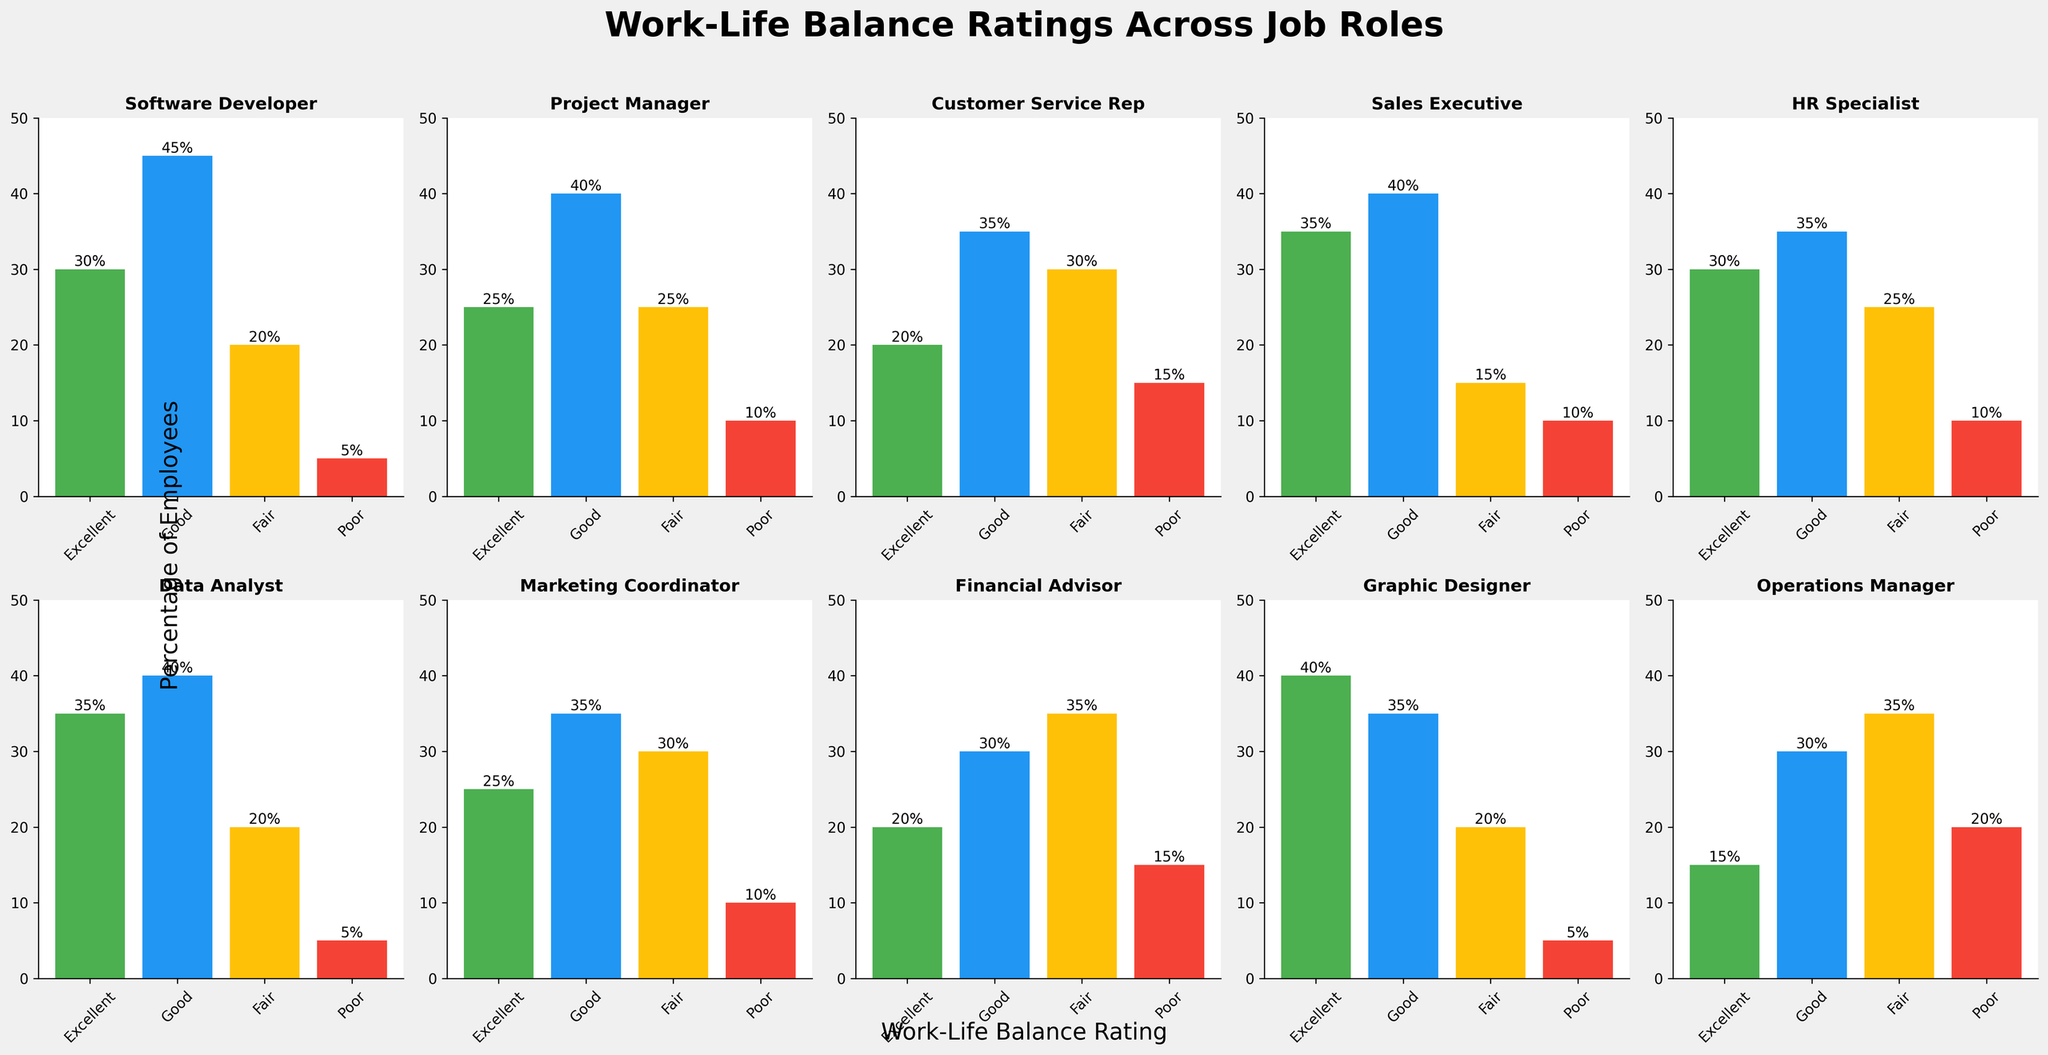What is the title of the figure? The title of the figure is usually placed at the top center and is typically printed in bold for better visibility. In this case, since the plot generation code specifies the title at the beginning, the title is "Work-Life Balance Ratings Across Job Roles."
Answer: Work-Life Balance Ratings Across Job Roles What job role has the highest percentage of employees rating their work-life balance as poor? The bar representing the percentage of employees rating their work-life balance as poor is the one with the red color ('#F44336'). By examining the graph, the Operations Manager role shows the highest percentage for the poor rating category, at 20%.
Answer: Operations Manager Which job role has the most employees rating their work-life balance as excellent? The green bar represents the excellent rating ('#4CAF50'). By looking at the height of these green bars, the job role with the tallest green bar can be identified. The Graphic Designer role has the highest percentage of employees rating their work-life balance as excellent, at 40%.
Answer: Graphic Designer What is the combined percentage of employees in the Customer Service Rep category who rated their work-life balance as either fair or poor? To find this combined percentage, add the values represented by the yellow (fair) and red (poor) bars for the Customer Service Rep role. The yellow bar is 30% and the red bar is 15%, so the combined percentage is 30% + 15% = 45%.
Answer: 45% Compare the "Good" ratings between Software Developer and Project Manager roles. Which one has a higher percentage? To compare, look at the blue bars for both roles. The Software Developer role has a blue bar at 45%, while the Project Manager role has a blue bar at 40%. Therefore, the Software Developer role has a higher percentage of good ratings.
Answer: Software Developer What is the sum of all "Excellent" ratings percentages across all job roles? Sum the values of the green bars for each job role: Software Developer (30), Project Manager (25), Customer Service Rep (20), Sales Executive (35), HR Specialist (30), Data Analyst (35), Marketing Coordinator (25), Financial Advisor (20), Graphic Designer (40), and Operations Manager (15). The total sum is 30 + 25 + 20 + 35 + 30 + 35 + 25 + 20 + 40 + 15 = 275.
Answer: 275 Which job role has the smallest difference between the percentage of employees rating work-life balance as excellent and those rating it as poor? To find this, calculate the difference between excellent and poor ratings for each job role, and find the smallest difference. Software Developer: 30 - 5 = 25, Project Manager: 25 - 10 = 15, Customer Service Rep: 20 - 15 = 5, Sales Executive: 35 - 10 = 25, HR Specialist: 30 - 10 = 20, Data Analyst: 35 - 5 = 30, Marketing Coordinator: 25 - 10 = 15, Financial Advisor: 20 - 15 = 5, Graphic Designer: 40 - 5 = 35, Operations Manager: 15 - 20 = -5. The Operations Manager role has the smallest difference, -5.
Answer: Operations Manager 